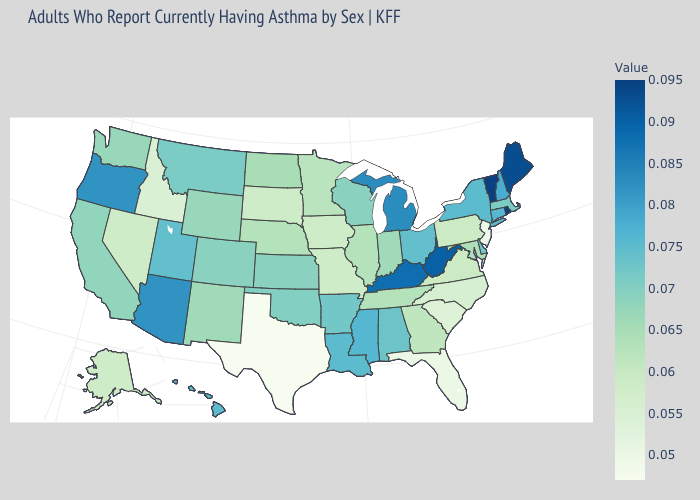Among the states that border Nebraska , which have the highest value?
Answer briefly. Colorado, Kansas. Does Idaho have the lowest value in the West?
Be succinct. Yes. Among the states that border Illinois , which have the lowest value?
Concise answer only. Iowa, Missouri. Which states have the highest value in the USA?
Quick response, please. Rhode Island, Vermont. Does Wyoming have the lowest value in the USA?
Keep it brief. No. Among the states that border Arizona , which have the highest value?
Concise answer only. Utah. 